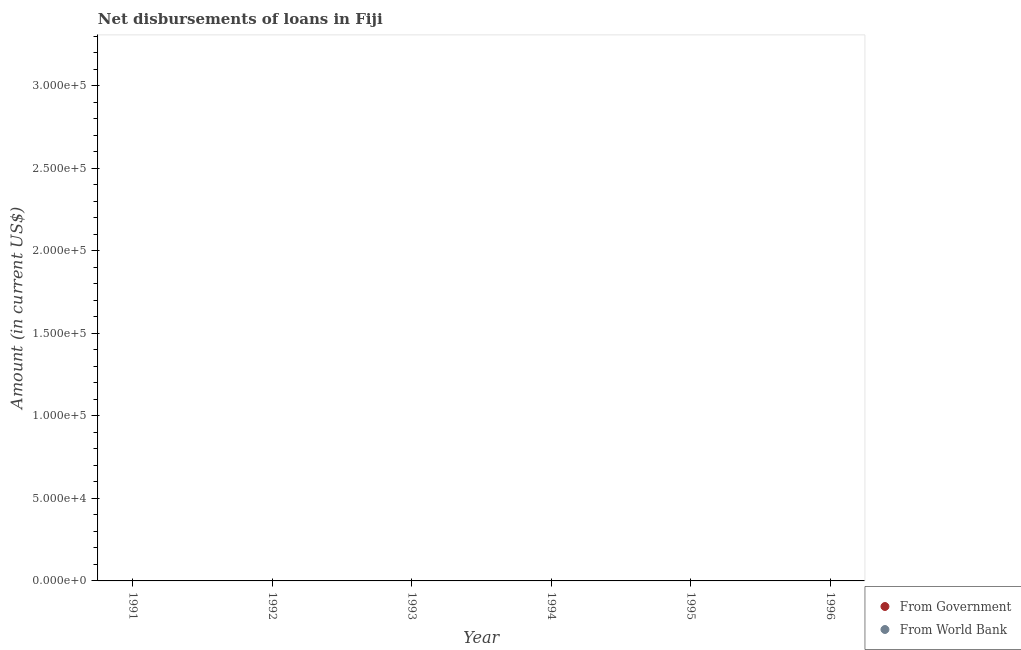How many different coloured dotlines are there?
Offer a very short reply. 0. Is the number of dotlines equal to the number of legend labels?
Provide a succinct answer. No. Across all years, what is the minimum net disbursements of loan from world bank?
Offer a very short reply. 0. What is the total net disbursements of loan from government in the graph?
Ensure brevity in your answer.  0. In how many years, is the net disbursements of loan from world bank greater than 150000 US$?
Provide a succinct answer. 0. In how many years, is the net disbursements of loan from government greater than the average net disbursements of loan from government taken over all years?
Your answer should be very brief. 0. Does the net disbursements of loan from government monotonically increase over the years?
Your answer should be compact. No. Is the net disbursements of loan from world bank strictly greater than the net disbursements of loan from government over the years?
Ensure brevity in your answer.  No. Is the net disbursements of loan from government strictly less than the net disbursements of loan from world bank over the years?
Give a very brief answer. No. How many years are there in the graph?
Offer a terse response. 6. What is the difference between two consecutive major ticks on the Y-axis?
Your answer should be very brief. 5.00e+04. Are the values on the major ticks of Y-axis written in scientific E-notation?
Offer a very short reply. Yes. What is the title of the graph?
Your response must be concise. Net disbursements of loans in Fiji. Does "Merchandise imports" appear as one of the legend labels in the graph?
Ensure brevity in your answer.  No. What is the label or title of the Y-axis?
Provide a succinct answer. Amount (in current US$). What is the Amount (in current US$) of From Government in 1991?
Keep it short and to the point. 0. What is the Amount (in current US$) in From World Bank in 1991?
Keep it short and to the point. 0. What is the Amount (in current US$) in From Government in 1994?
Provide a succinct answer. 0. What is the Amount (in current US$) of From World Bank in 1994?
Give a very brief answer. 0. What is the Amount (in current US$) in From Government in 1995?
Ensure brevity in your answer.  0. What is the Amount (in current US$) in From World Bank in 1995?
Keep it short and to the point. 0. What is the Amount (in current US$) in From World Bank in 1996?
Keep it short and to the point. 0. What is the total Amount (in current US$) of From Government in the graph?
Offer a very short reply. 0. What is the average Amount (in current US$) of From Government per year?
Keep it short and to the point. 0. What is the average Amount (in current US$) of From World Bank per year?
Provide a succinct answer. 0. 